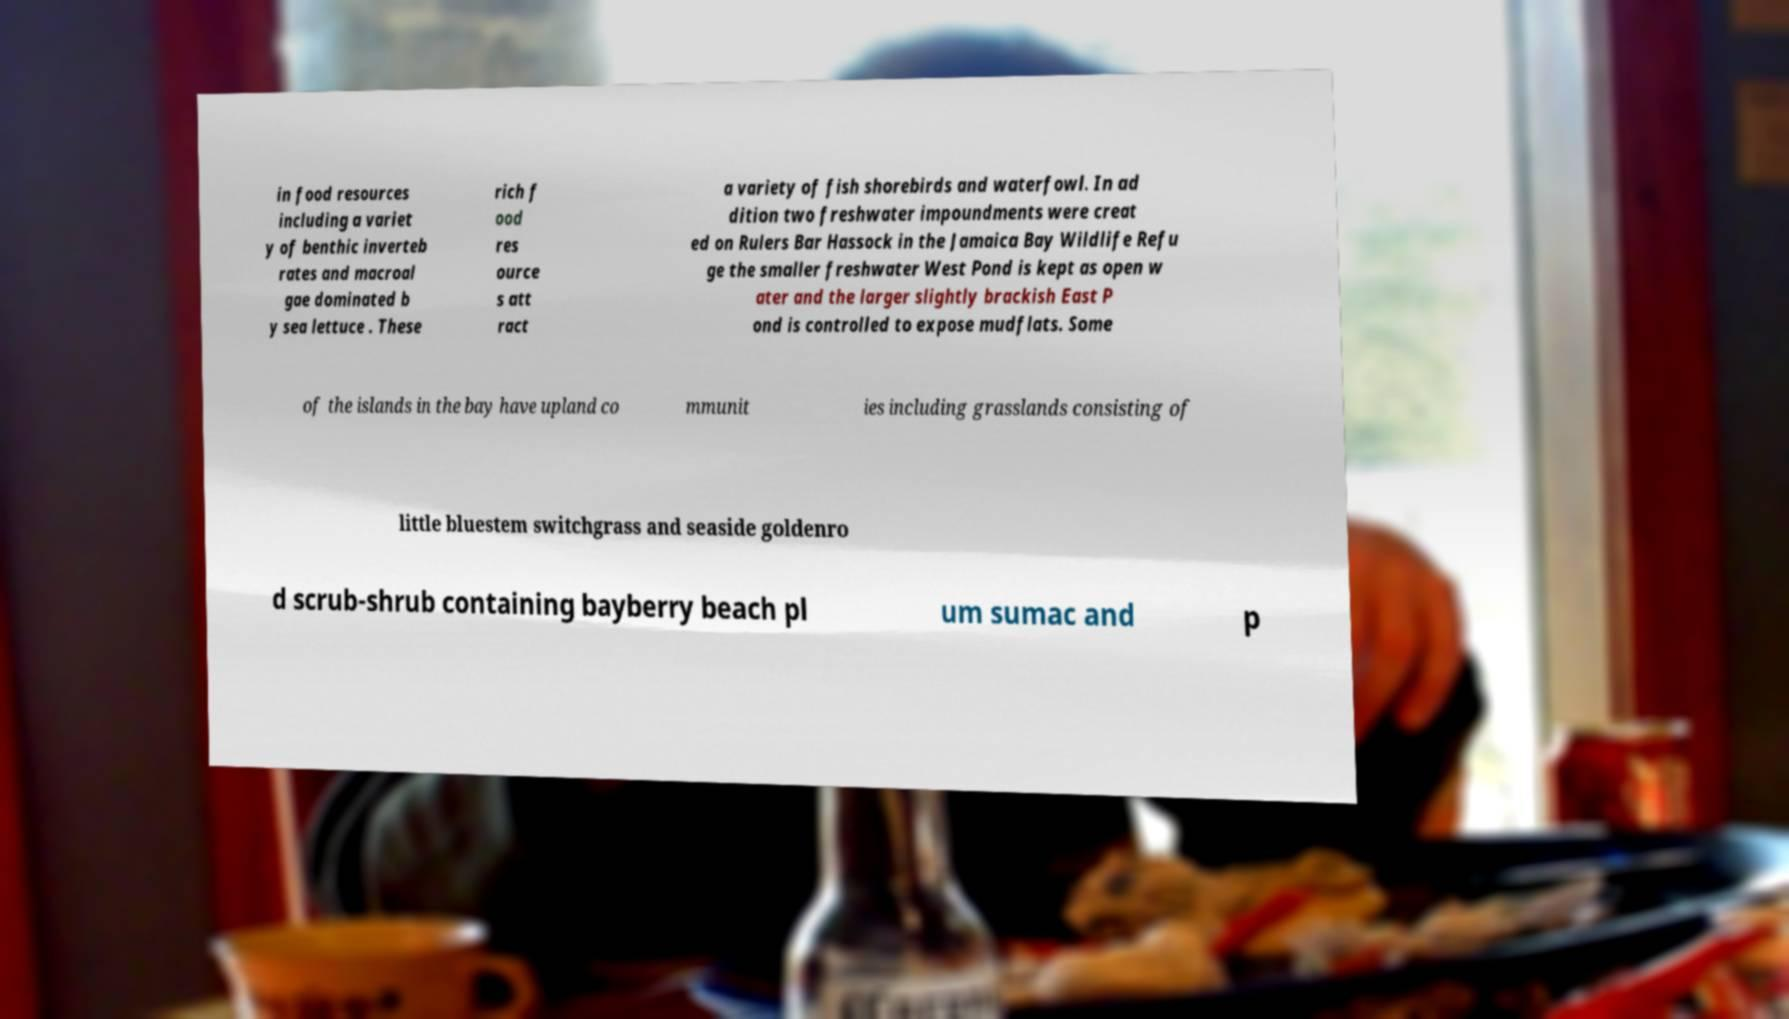Could you extract and type out the text from this image? in food resources including a variet y of benthic inverteb rates and macroal gae dominated b y sea lettuce . These rich f ood res ource s att ract a variety of fish shorebirds and waterfowl. In ad dition two freshwater impoundments were creat ed on Rulers Bar Hassock in the Jamaica Bay Wildlife Refu ge the smaller freshwater West Pond is kept as open w ater and the larger slightly brackish East P ond is controlled to expose mudflats. Some of the islands in the bay have upland co mmunit ies including grasslands consisting of little bluestem switchgrass and seaside goldenro d scrub-shrub containing bayberry beach pl um sumac and p 